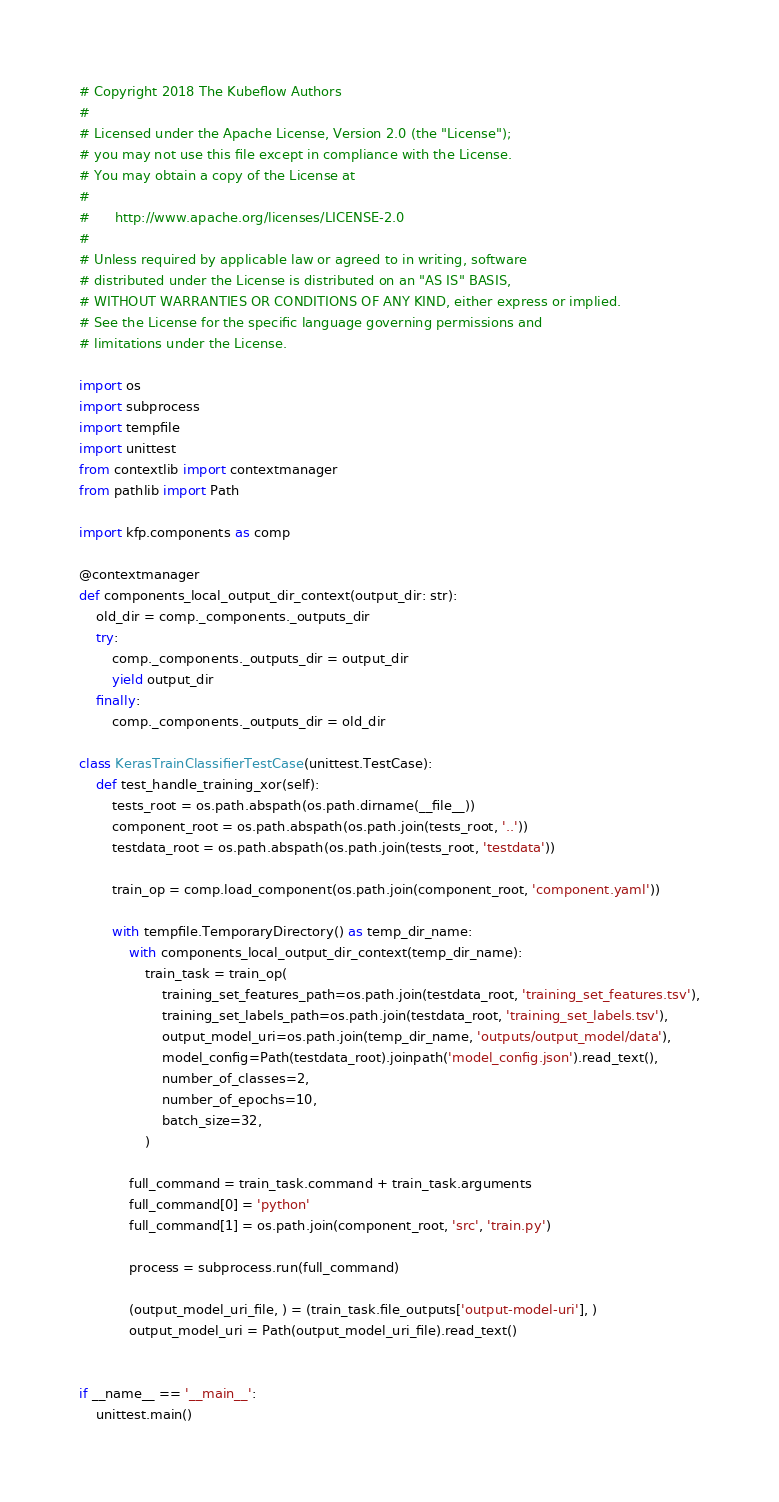Convert code to text. <code><loc_0><loc_0><loc_500><loc_500><_Python_># Copyright 2018 The Kubeflow Authors
#
# Licensed under the Apache License, Version 2.0 (the "License");
# you may not use this file except in compliance with the License.
# You may obtain a copy of the License at
#
#      http://www.apache.org/licenses/LICENSE-2.0
#
# Unless required by applicable law or agreed to in writing, software
# distributed under the License is distributed on an "AS IS" BASIS,
# WITHOUT WARRANTIES OR CONDITIONS OF ANY KIND, either express or implied.
# See the License for the specific language governing permissions and
# limitations under the License.

import os
import subprocess
import tempfile
import unittest
from contextlib import contextmanager
from pathlib import Path

import kfp.components as comp

@contextmanager
def components_local_output_dir_context(output_dir: str):
    old_dir = comp._components._outputs_dir
    try:
        comp._components._outputs_dir = output_dir
        yield output_dir
    finally:
        comp._components._outputs_dir = old_dir

class KerasTrainClassifierTestCase(unittest.TestCase):
    def test_handle_training_xor(self):
        tests_root = os.path.abspath(os.path.dirname(__file__))
        component_root = os.path.abspath(os.path.join(tests_root, '..'))
        testdata_root = os.path.abspath(os.path.join(tests_root, 'testdata'))
        
        train_op = comp.load_component(os.path.join(component_root, 'component.yaml'))

        with tempfile.TemporaryDirectory() as temp_dir_name:
            with components_local_output_dir_context(temp_dir_name):
                train_task = train_op(
                    training_set_features_path=os.path.join(testdata_root, 'training_set_features.tsv'),
                    training_set_labels_path=os.path.join(testdata_root, 'training_set_labels.tsv'),
                    output_model_uri=os.path.join(temp_dir_name, 'outputs/output_model/data'),
                    model_config=Path(testdata_root).joinpath('model_config.json').read_text(),
                    number_of_classes=2,
                    number_of_epochs=10,
                    batch_size=32,
                )

            full_command = train_task.command + train_task.arguments
            full_command[0] = 'python'
            full_command[1] = os.path.join(component_root, 'src', 'train.py')

            process = subprocess.run(full_command)

            (output_model_uri_file, ) = (train_task.file_outputs['output-model-uri'], )
            output_model_uri = Path(output_model_uri_file).read_text()


if __name__ == '__main__':
    unittest.main()
</code> 